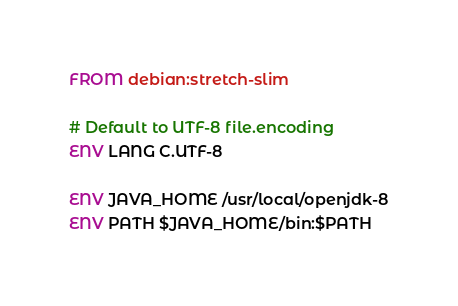Convert code to text. <code><loc_0><loc_0><loc_500><loc_500><_Dockerfile_>FROM debian:stretch-slim

# Default to UTF-8 file.encoding
ENV LANG C.UTF-8

ENV JAVA_HOME /usr/local/openjdk-8
ENV PATH $JAVA_HOME/bin:$PATH
</code> 